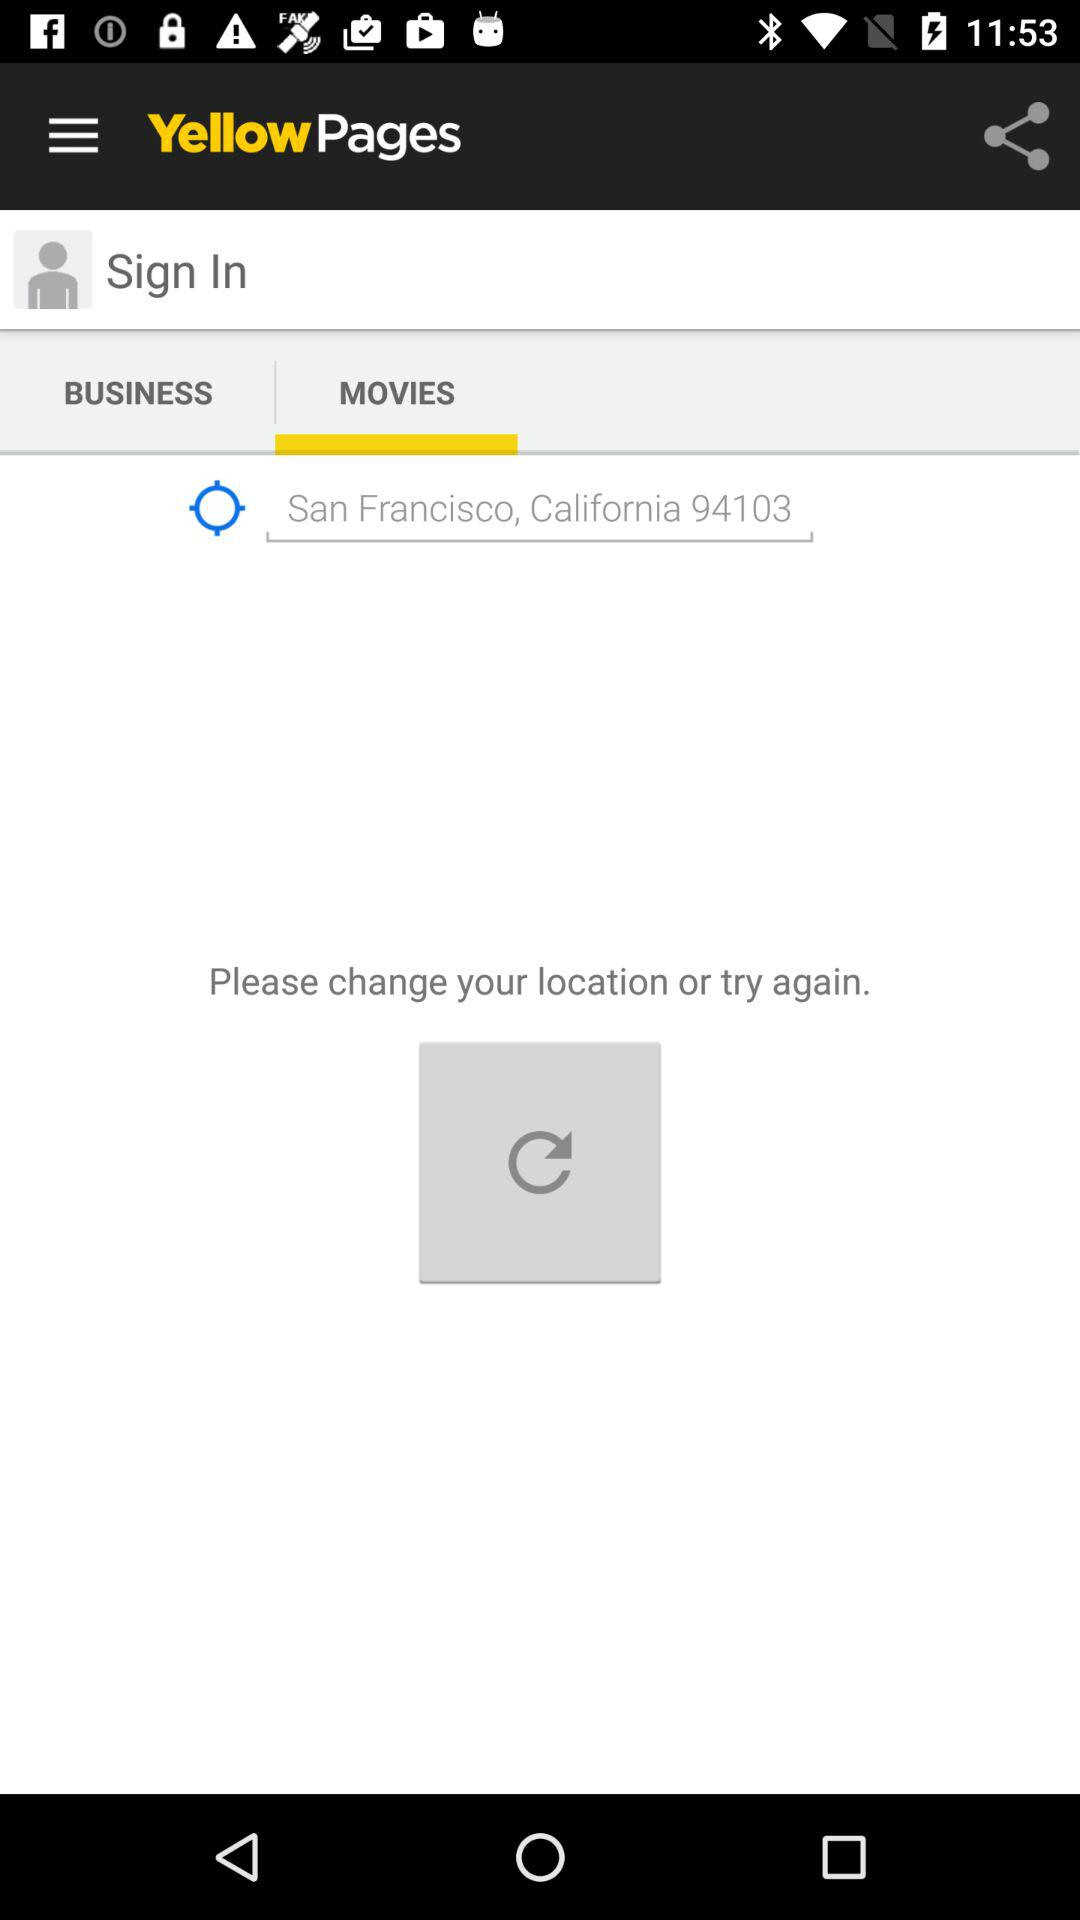What is the app name? The app name is "Yellow Pages". 